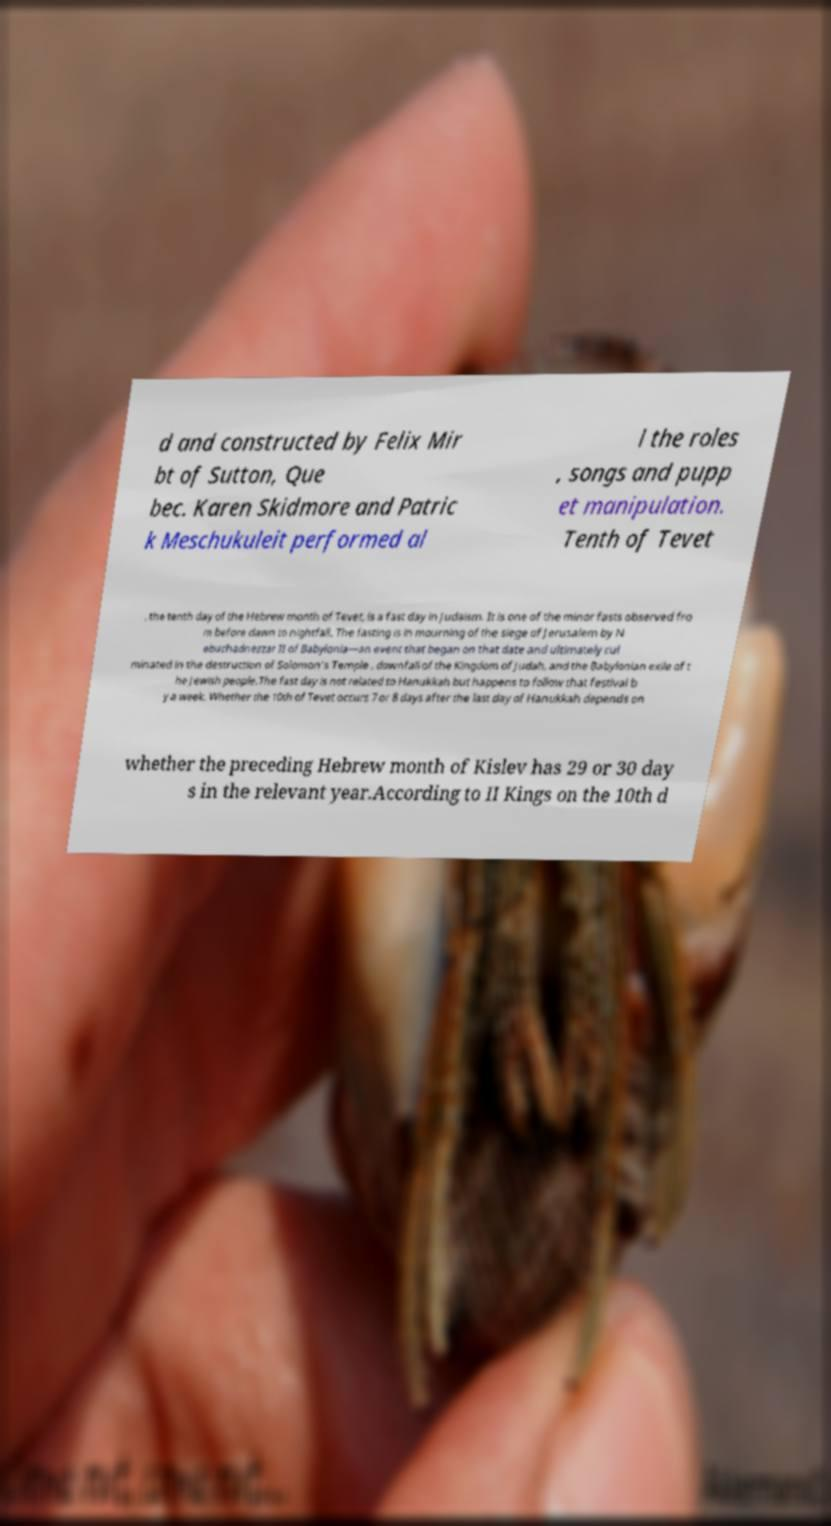I need the written content from this picture converted into text. Can you do that? d and constructed by Felix Mir bt of Sutton, Que bec. Karen Skidmore and Patric k Meschukuleit performed al l the roles , songs and pupp et manipulation. Tenth of Tevet , the tenth day of the Hebrew month of Tevet, is a fast day in Judaism. It is one of the minor fasts observed fro m before dawn to nightfall. The fasting is in mourning of the siege of Jerusalem by N ebuchadnezzar II of Babylonia—an event that began on that date and ultimately cul minated in the destruction of Solomon's Temple , downfall of the Kingdom of Judah, and the Babylonian exile of t he Jewish people.The fast day is not related to Hanukkah but happens to follow that festival b y a week. Whether the 10th of Tevet occurs 7 or 8 days after the last day of Hanukkah depends on whether the preceding Hebrew month of Kislev has 29 or 30 day s in the relevant year.According to II Kings on the 10th d 